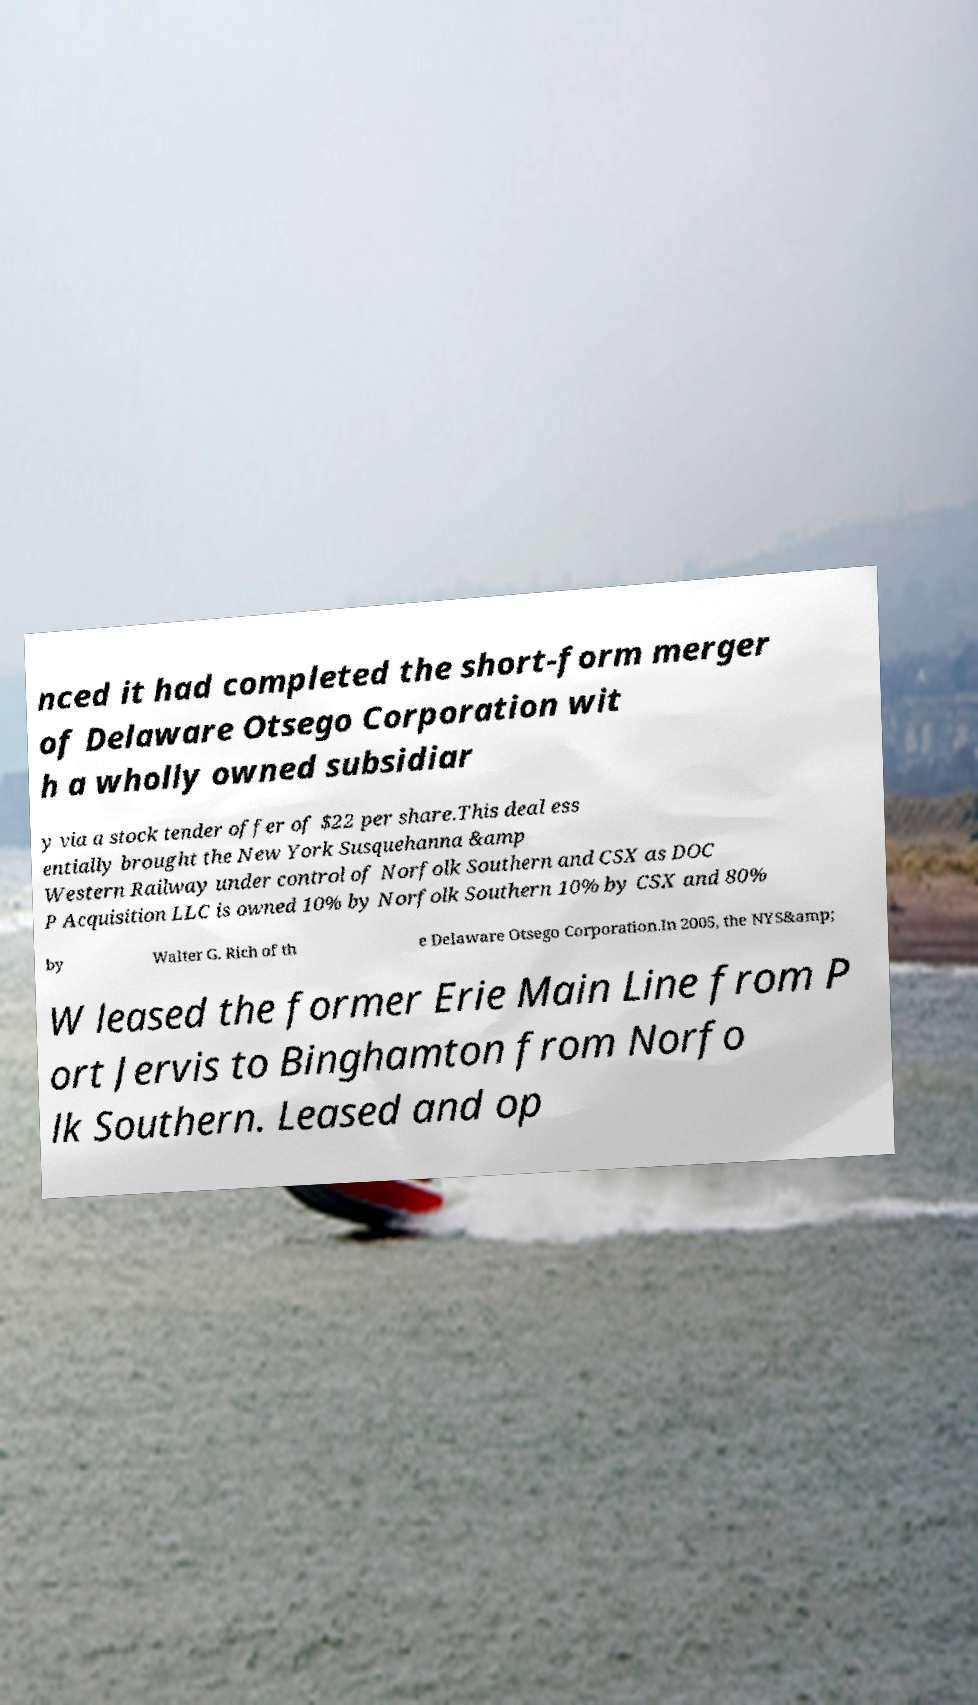What messages or text are displayed in this image? I need them in a readable, typed format. nced it had completed the short-form merger of Delaware Otsego Corporation wit h a wholly owned subsidiar y via a stock tender offer of $22 per share.This deal ess entially brought the New York Susquehanna &amp Western Railway under control of Norfolk Southern and CSX as DOC P Acquisition LLC is owned 10% by Norfolk Southern 10% by CSX and 80% by Walter G. Rich of th e Delaware Otsego Corporation.In 2005, the NYS&amp; W leased the former Erie Main Line from P ort Jervis to Binghamton from Norfo lk Southern. Leased and op 